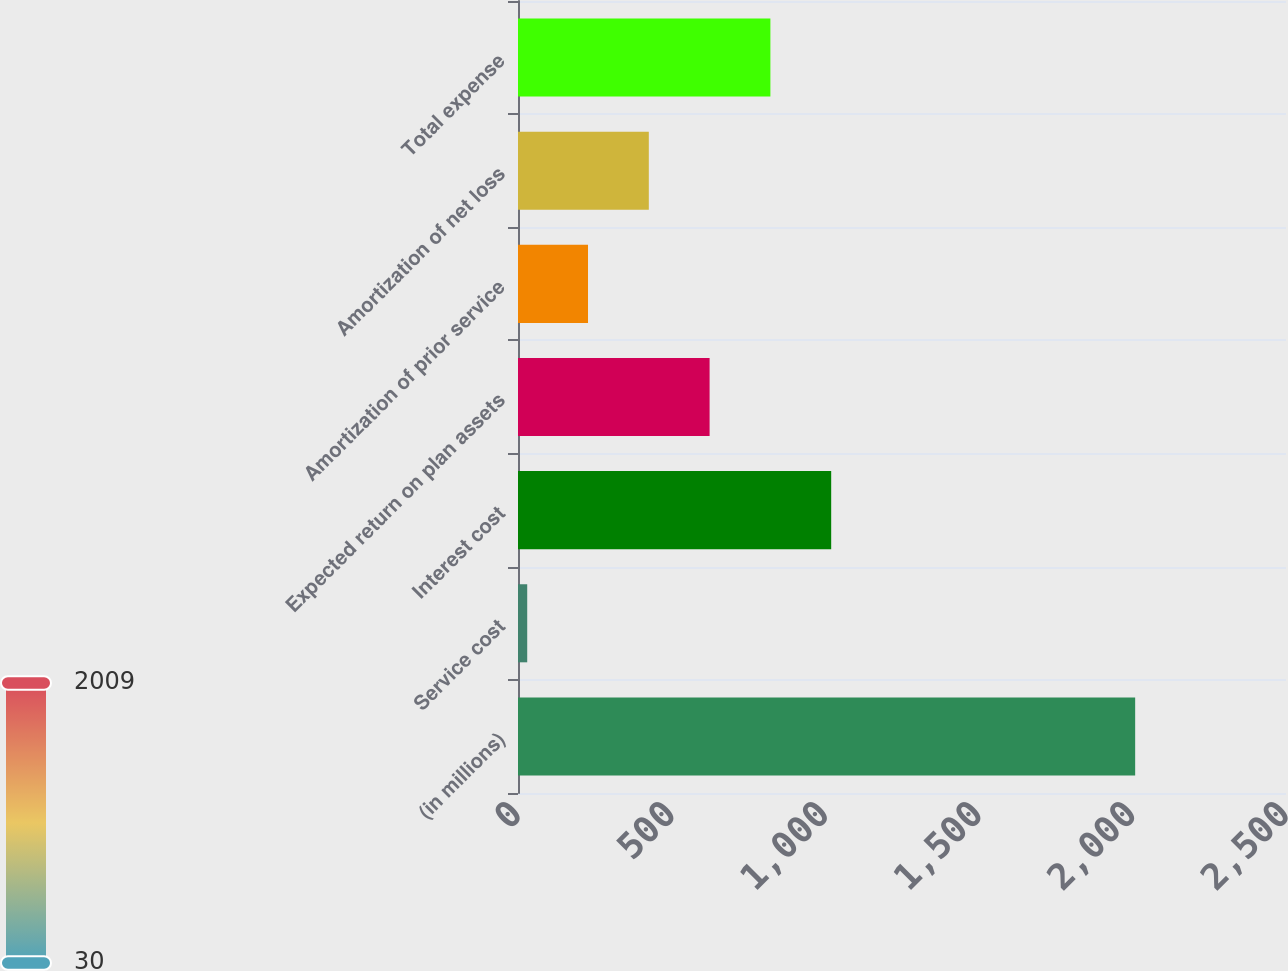Convert chart. <chart><loc_0><loc_0><loc_500><loc_500><bar_chart><fcel>(in millions)<fcel>Service cost<fcel>Interest cost<fcel>Expected return on plan assets<fcel>Amortization of prior service<fcel>Amortization of net loss<fcel>Total expense<nl><fcel>2009<fcel>30<fcel>1019.5<fcel>623.7<fcel>227.9<fcel>425.8<fcel>821.6<nl></chart> 